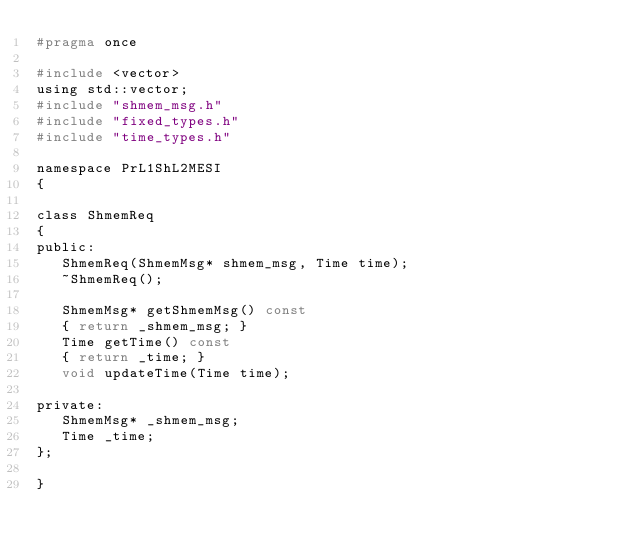<code> <loc_0><loc_0><loc_500><loc_500><_C_>#pragma once

#include <vector>
using std::vector;
#include "shmem_msg.h"
#include "fixed_types.h"
#include "time_types.h"

namespace PrL1ShL2MESI
{

class ShmemReq
{
public:
   ShmemReq(ShmemMsg* shmem_msg, Time time);
   ~ShmemReq();

   ShmemMsg* getShmemMsg() const
   { return _shmem_msg; }
   Time getTime() const
   { return _time; }
   void updateTime(Time time);

private:
   ShmemMsg* _shmem_msg;
   Time _time;
};

}
</code> 